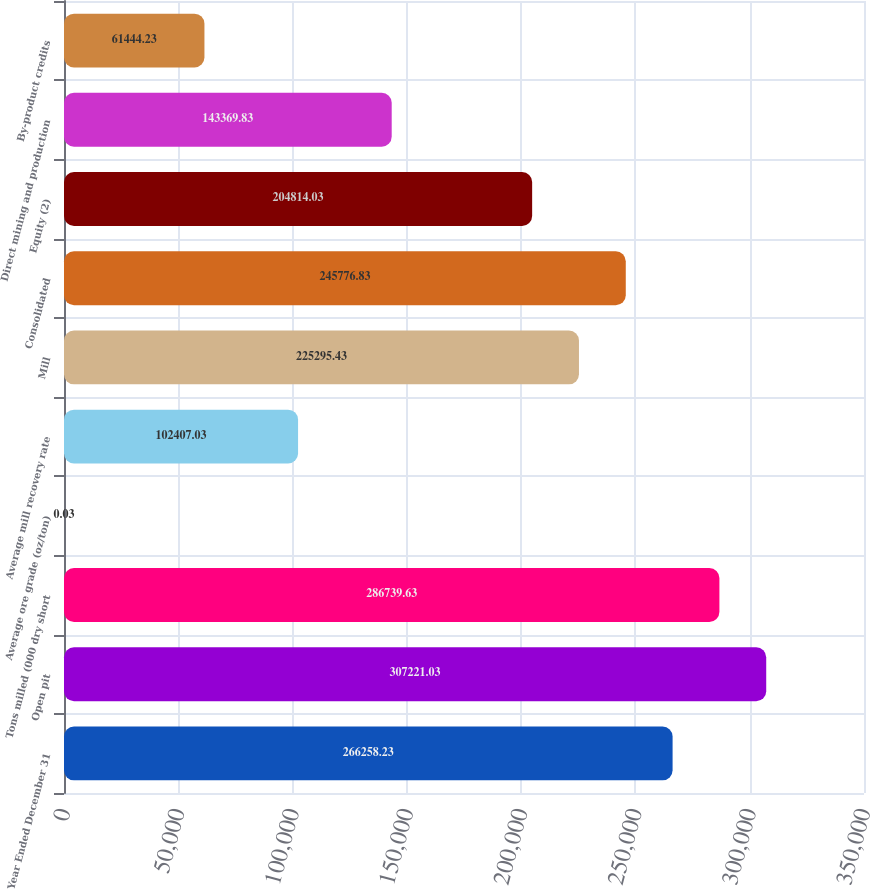Convert chart to OTSL. <chart><loc_0><loc_0><loc_500><loc_500><bar_chart><fcel>Year Ended December 31<fcel>Open pit<fcel>Tons milled (000 dry short<fcel>Average ore grade (oz/ton)<fcel>Average mill recovery rate<fcel>Mill<fcel>Consolidated<fcel>Equity (2)<fcel>Direct mining and production<fcel>By-product credits<nl><fcel>266258<fcel>307221<fcel>286740<fcel>0.03<fcel>102407<fcel>225295<fcel>245777<fcel>204814<fcel>143370<fcel>61444.2<nl></chart> 